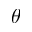Convert formula to latex. <formula><loc_0><loc_0><loc_500><loc_500>\theta</formula> 